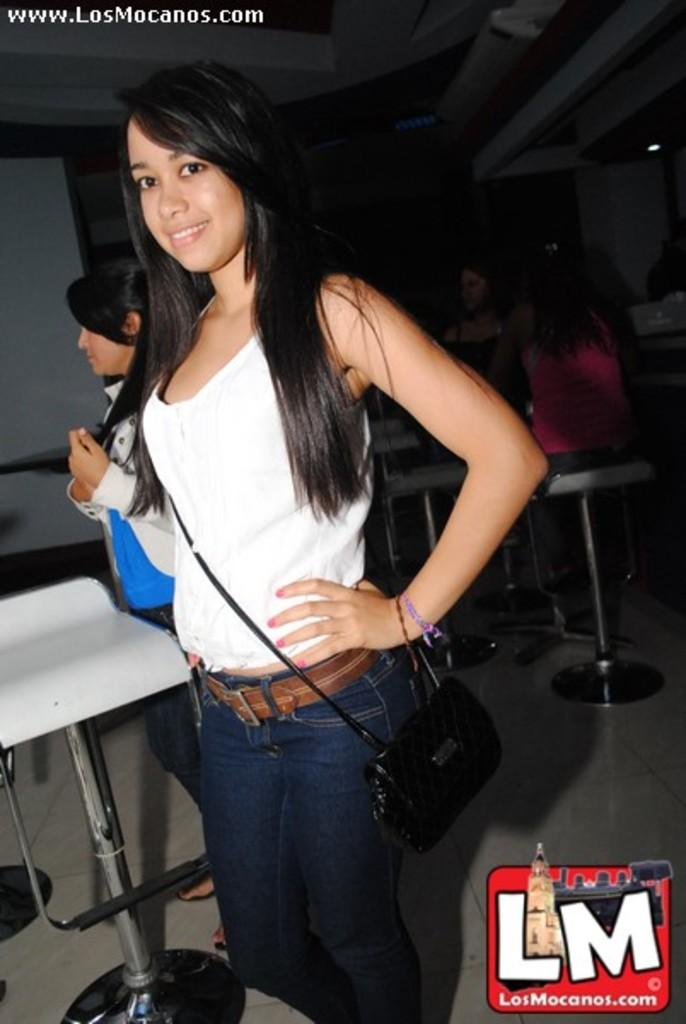Who is present in the image? There is a woman in the image. What is the woman doing in the image? The woman is standing and smiling. What type of furniture can be seen in the image? There are chairs and tables in the image. How many ladybugs can be seen on the woman's shoulder in the image? There are no ladybugs present in the image. What type of cable is connected to the woman's ear in the image? There is no cable connected to the woman's ear in the image. 